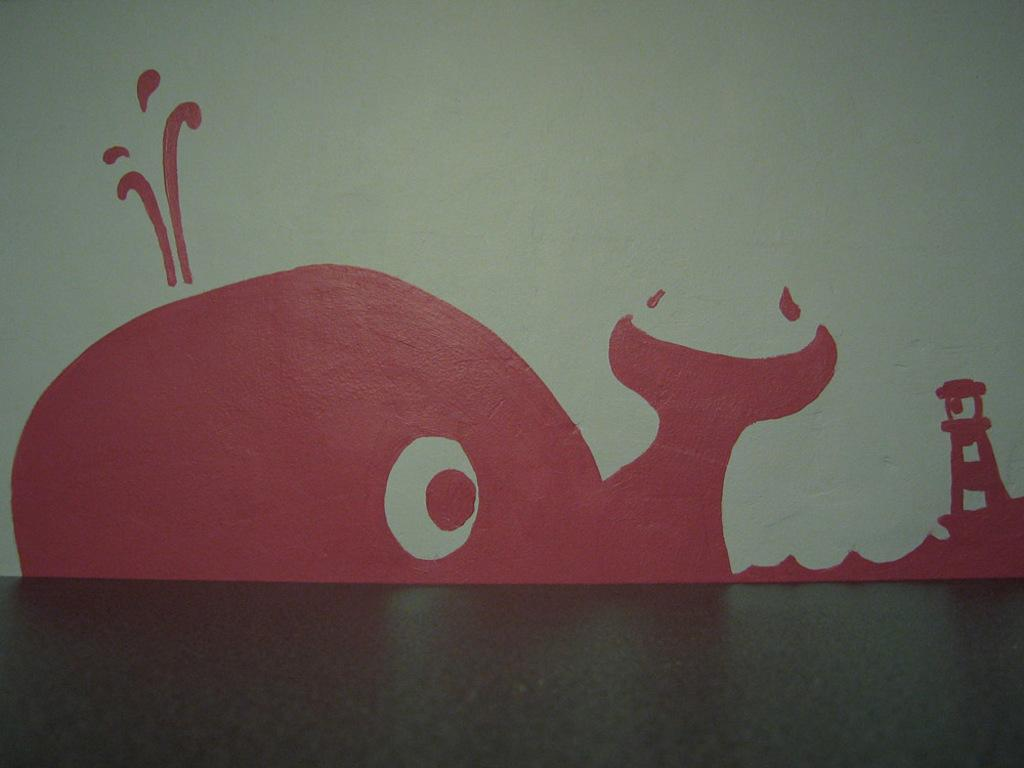What is on the wall in the image? There is a painting on the wall in the image. What is depicted in the painting? The painting depicts a dolphin and a lighthouse. What color is the painting? The painting is in pink color. What color is the wall? The wall is in light green color. How many geese are flying in the painting? There are no geese depicted in the painting; it features a dolphin and a lighthouse. 